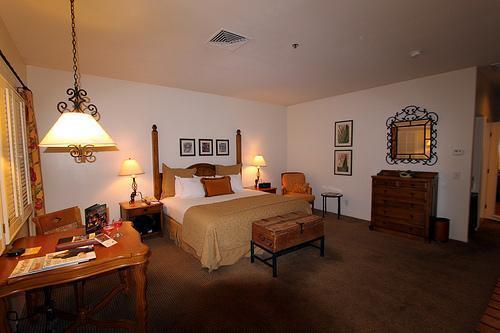How many end tables do you see?
Give a very brief answer. 2. How many dressers do you see?
Give a very brief answer. 1. 